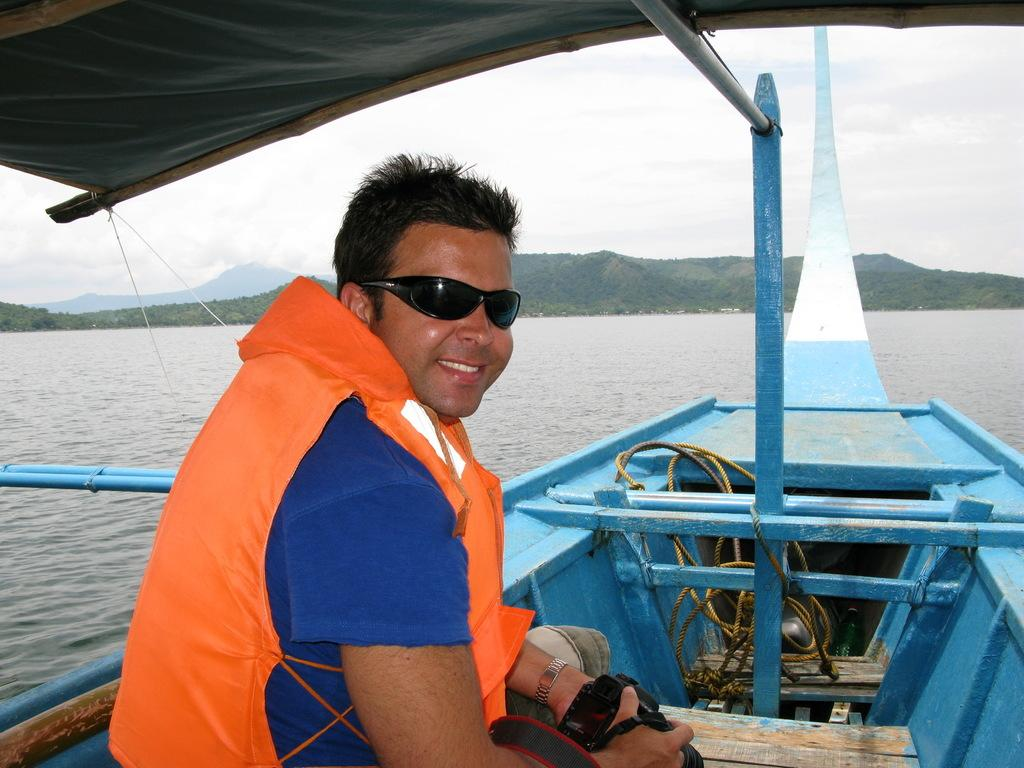What is the person in the image doing? The person is sitting on a boat in the image. What can be seen in the background of the image? There is water, trees, mountains, and the sky visible in the background of the image. What time of day was the image taken? The image was taken during the day. Where was the image taken? The image was taken near the ocean. Can you see a man looking at a swing in the image? There is no man looking at a swing in the image; it only shows a person sitting on a boat. 